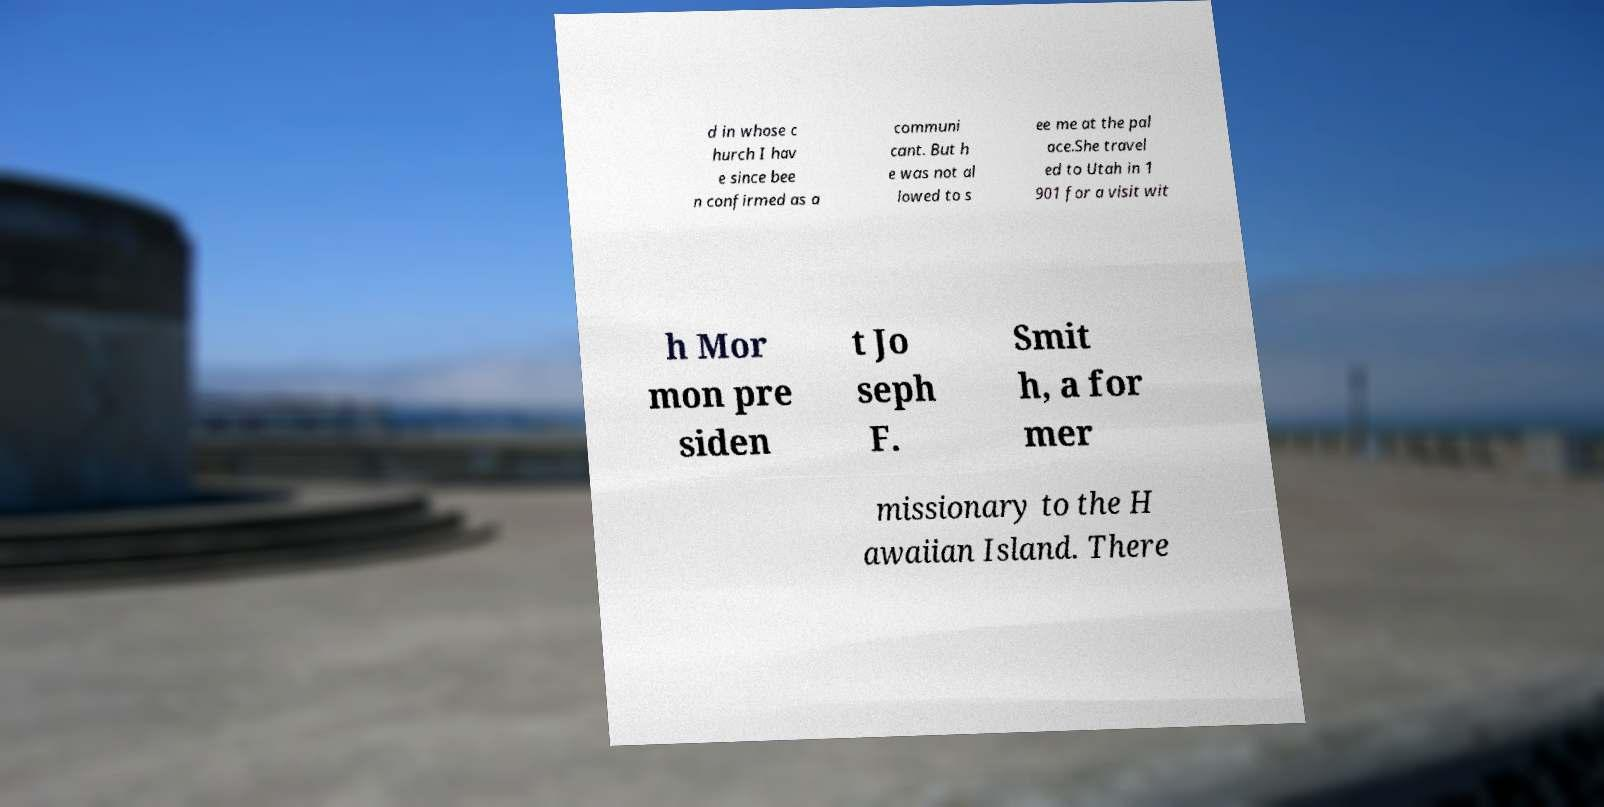Can you read and provide the text displayed in the image?This photo seems to have some interesting text. Can you extract and type it out for me? d in whose c hurch I hav e since bee n confirmed as a communi cant. But h e was not al lowed to s ee me at the pal ace.She travel ed to Utah in 1 901 for a visit wit h Mor mon pre siden t Jo seph F. Smit h, a for mer missionary to the H awaiian Island. There 